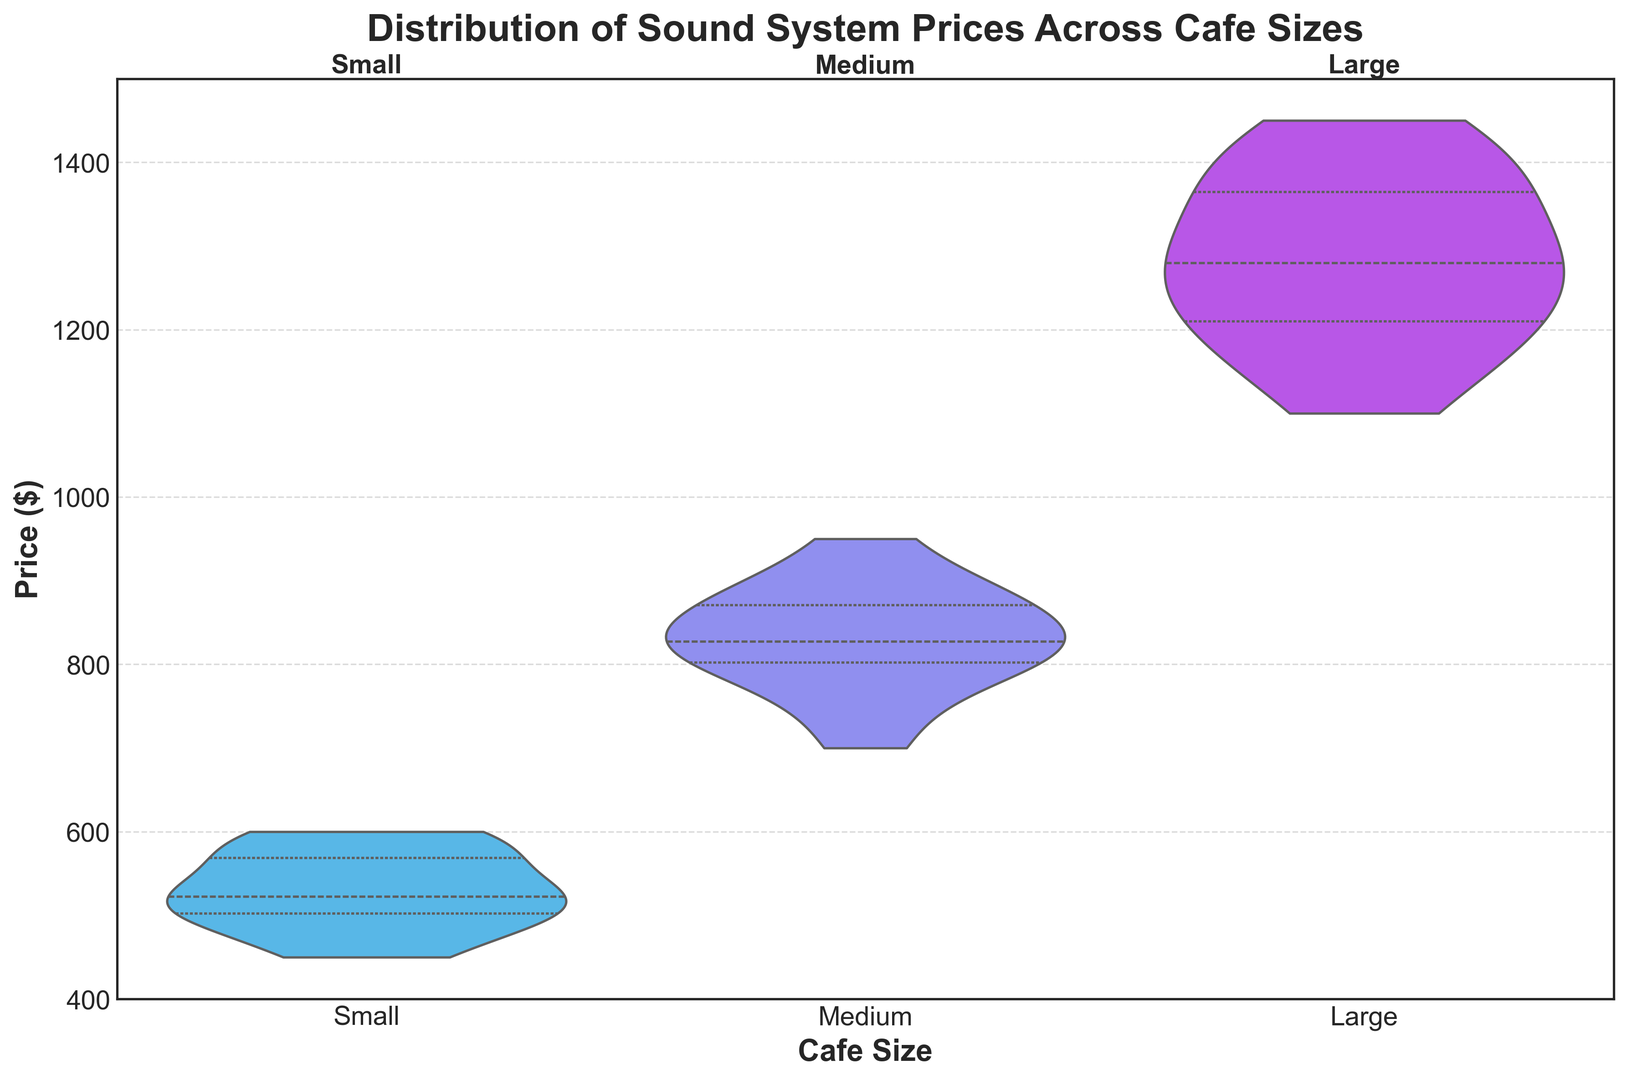What is the median price of sound systems for medium-sized cafes? Locate the medium-sized cafe section on the plot. The median is represented by the central horizontal line within the violin. Identify the value of this line in the medium-sized violin.
Answer: $825 Which cafe size has the widest range of sound system prices? Compare the height of each violin plot for the different cafe sizes. The widest range will be indicated by the tallest violin plot.
Answer: Large How do the interquartile ranges of sound system prices compare between small and large cafes? Examine the width of the central part of each violin plot, which represents the interquartile range. Compare the width of the small cafe plot with the large cafe plot.
Answer: The interquartile range is wider in the large cafes What is the maximum price of sound systems for small-sized cafes? Identify the top boundary of the small cafe's violin plot. The maximum price is located at the topmost point of this plot.
Answer: $600 Which cafe size has the highest median sound system price? Identify the central horizontal line within each violin plot for all cafe sizes. The highest median will be represented by the highest central line.
Answer: Large What is the approximate price range covered by the medium-sized cafe sound systems? Identify the bottom and top boundaries of the medium-sized cafe’s violin plot. Determine the numerical values corresponding to these boundaries.
Answer: $700 - $950 Are there any cafe sizes where the median price is outside the interquartile range of another size? Compare the position of the median line in each cafe size’s violin plot with the interquartile range (central width) of the other cafe sizes.
Answer: No, each median price falls within the interquartile range of that same cafe size 